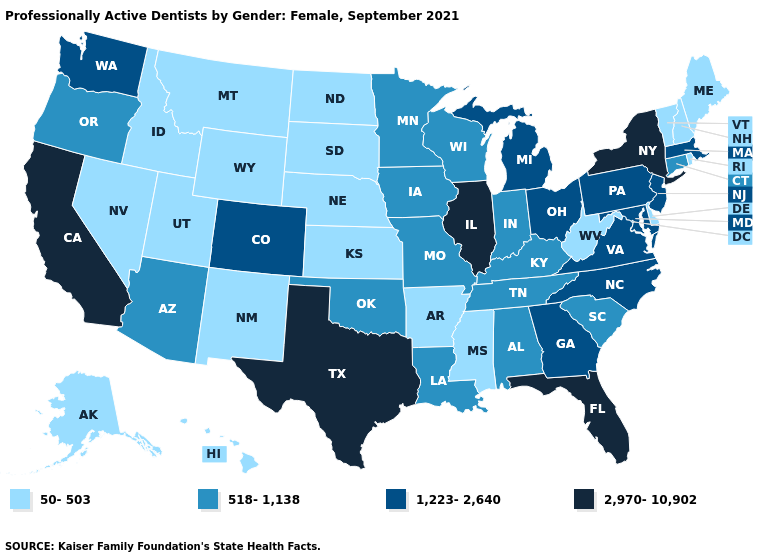What is the value of New Hampshire?
Answer briefly. 50-503. Name the states that have a value in the range 518-1,138?
Keep it brief. Alabama, Arizona, Connecticut, Indiana, Iowa, Kentucky, Louisiana, Minnesota, Missouri, Oklahoma, Oregon, South Carolina, Tennessee, Wisconsin. What is the value of West Virginia?
Write a very short answer. 50-503. Among the states that border South Carolina , which have the lowest value?
Give a very brief answer. Georgia, North Carolina. Name the states that have a value in the range 518-1,138?
Be succinct. Alabama, Arizona, Connecticut, Indiana, Iowa, Kentucky, Louisiana, Minnesota, Missouri, Oklahoma, Oregon, South Carolina, Tennessee, Wisconsin. Is the legend a continuous bar?
Concise answer only. No. What is the value of Massachusetts?
Concise answer only. 1,223-2,640. Which states hav the highest value in the South?
Concise answer only. Florida, Texas. Name the states that have a value in the range 50-503?
Write a very short answer. Alaska, Arkansas, Delaware, Hawaii, Idaho, Kansas, Maine, Mississippi, Montana, Nebraska, Nevada, New Hampshire, New Mexico, North Dakota, Rhode Island, South Dakota, Utah, Vermont, West Virginia, Wyoming. Does the map have missing data?
Write a very short answer. No. Among the states that border Nevada , does California have the highest value?
Answer briefly. Yes. Among the states that border Idaho , does Utah have the lowest value?
Answer briefly. Yes. Name the states that have a value in the range 2,970-10,902?
Write a very short answer. California, Florida, Illinois, New York, Texas. Among the states that border Kentucky , does West Virginia have the lowest value?
Be succinct. Yes. Does the map have missing data?
Write a very short answer. No. 